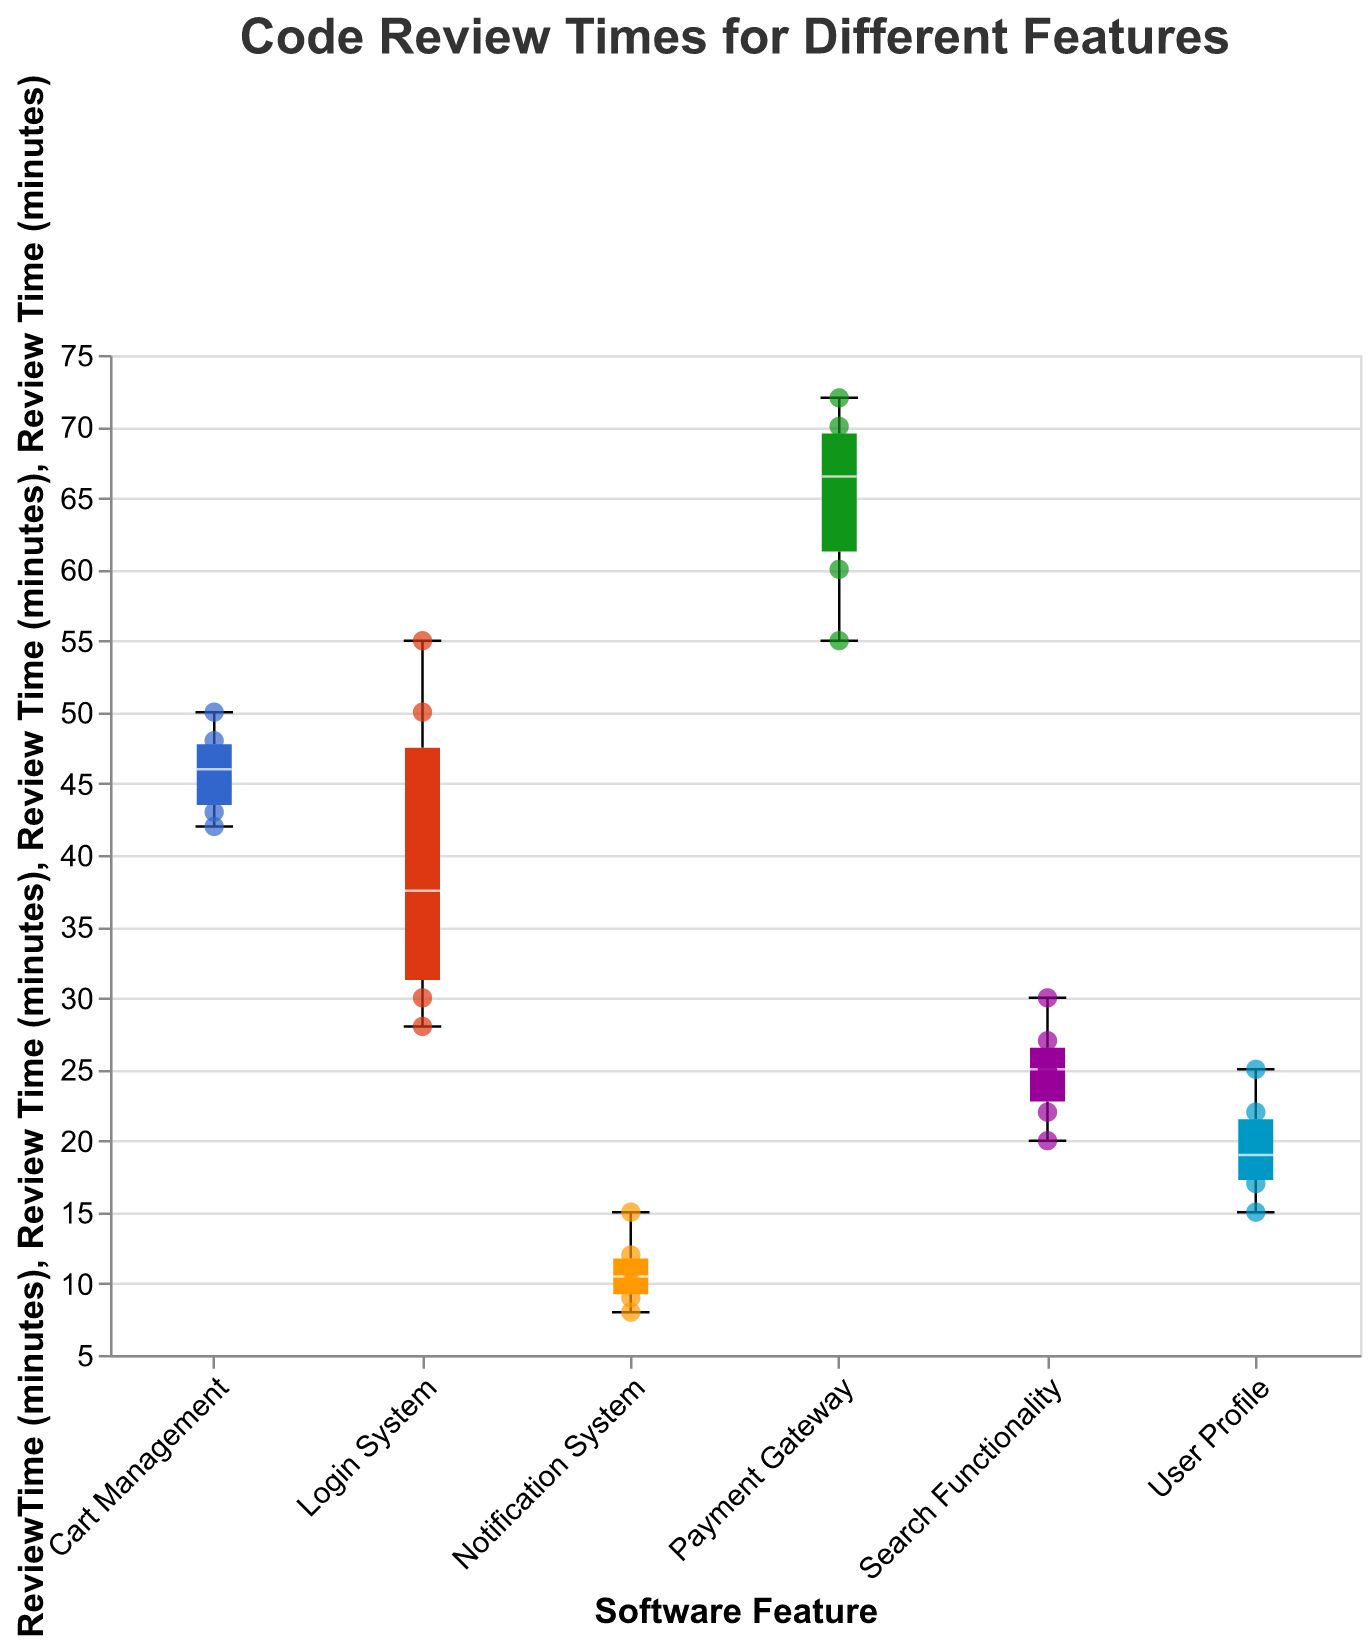What is the title of the figure? The title is displayed at the top of the figure and it is "Code Review Times for Different Features".
Answer: Code Review Times for Different Features Which feature has the median review time closest to 20 minutes? By examining the median lines of the box plots, the User Profile feature has its median line closest to the 20-minute mark.
Answer: User Profile What is the range of review times for the Login System feature? The extent of the box plot for the Login System extends from the minimum review time to the maximum review time. The minimum is 28 minutes and the maximum is 55 minutes.
Answer: 28 to 55 minutes How many outliers are present in the Payment Gateway feature? Outliers in a box plot are the points that fall outside the whiskers. There are no points outside the whiskers for Payment Gateway, hence no outliers.
Answer: 0 Which feature has the highest median review time? The median lines of the box plots need to be compared. The Payment Gateway feature has the highest median review time.
Answer: Payment Gateway What is the interquartile range (IQR) for the Search Functionality feature? The IQR is the range between the first quartile (Q1) and the third quartile (Q3). For Search Functionality, the Q1 is 22 minutes and the Q3 is 27 minutes. Therefore, the IQR is 27 - 22.
Answer: 5 minutes Compare the median review times of the Cart Management and Notification System features. Which is greater? The median lines of the box plots for Cart Management and Notification System need to be compared. Cart Management’s median is much higher than Notification System’s median.
Answer: Cart Management Which feature has the smallest range of review times? The range of review times is represented by the length between the minimum and maximum whiskers. The Notification System has the smallest range of review times.
Answer: Notification System What percentage of review times for the User Profile feature are less than the median review time of the Cart Management feature? Identify the median for Cart Management and count the User Profile review times below this value. The Cart Management median is around 45 minutes. All User Profile review times (15, 20, 22, 18, 25, 17) are below 45 minutes, making it 100%.
Answer: 100% Looking at the scatter points, which review time stands out as the highest individual review time across all features? By examining the scatter points (individual data points), the Payment Gateway feature has a review time of 72 minutes, which is the highest.
Answer: 72 minutes 